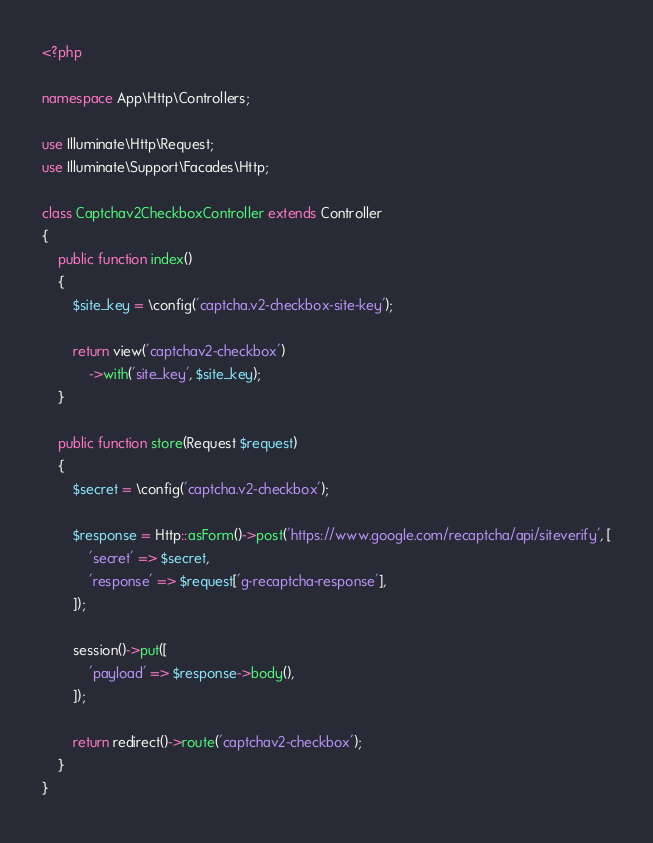Convert code to text. <code><loc_0><loc_0><loc_500><loc_500><_PHP_><?php

namespace App\Http\Controllers;

use Illuminate\Http\Request;
use Illuminate\Support\Facades\Http;

class Captchav2CheckboxController extends Controller
{
    public function index()
    {
        $site_key = \config('captcha.v2-checkbox-site-key');

        return view('captchav2-checkbox')
            ->with('site_key', $site_key);
    }

    public function store(Request $request)
    {
        $secret = \config('captcha.v2-checkbox');

        $response = Http::asForm()->post('https://www.google.com/recaptcha/api/siteverify', [
            'secret' => $secret,
            'response' => $request['g-recaptcha-response'],
        ]);

        session()->put([
            'payload' => $response->body(),
        ]);

        return redirect()->route('captchav2-checkbox');
    }
}
</code> 